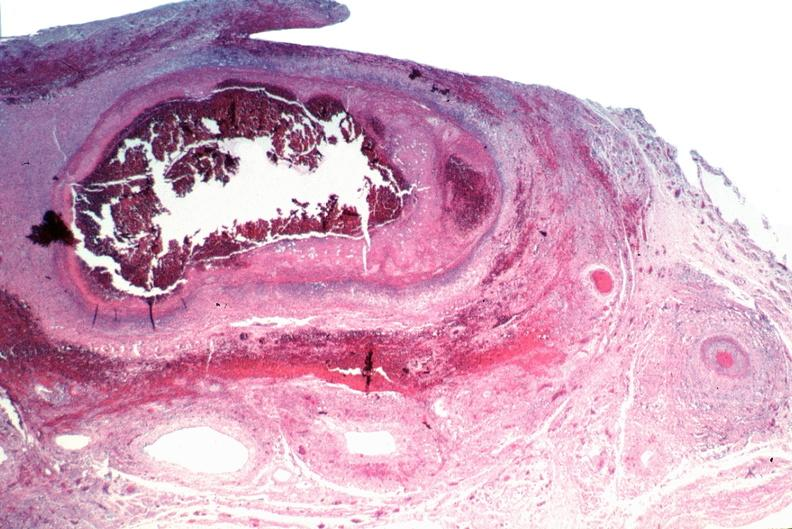what is present?
Answer the question using a single word or phrase. Vasculature 